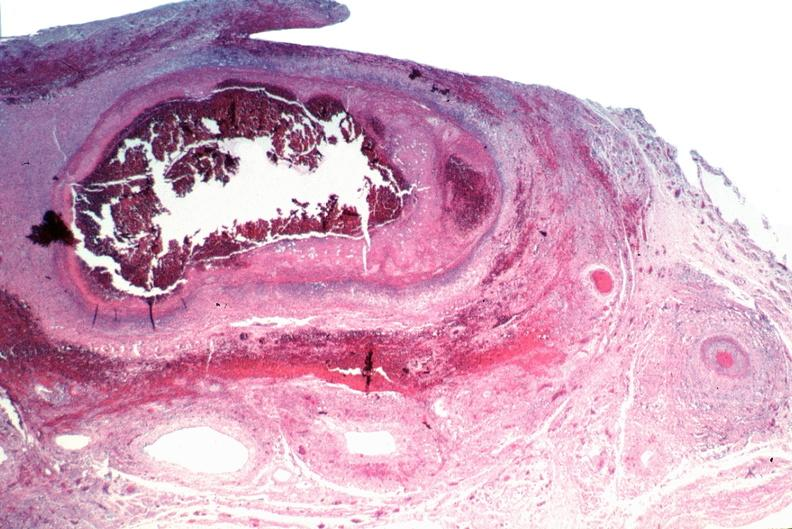what is present?
Answer the question using a single word or phrase. Vasculature 